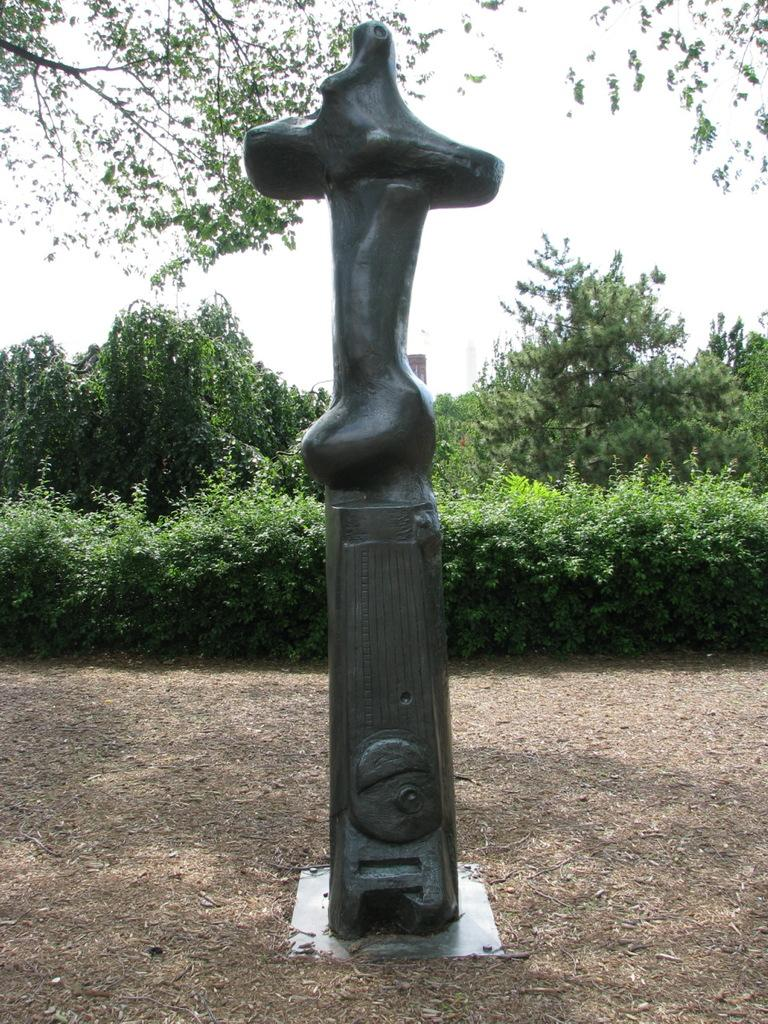What is the main subject in the image? There is a statue in the image. What can be seen in the background of the image? There are trees and plants in the background of the image. What is the value of the head on the statue in the image? There is no mention of a head on the statue in the image, and the concept of value does not apply to the statue's features. 